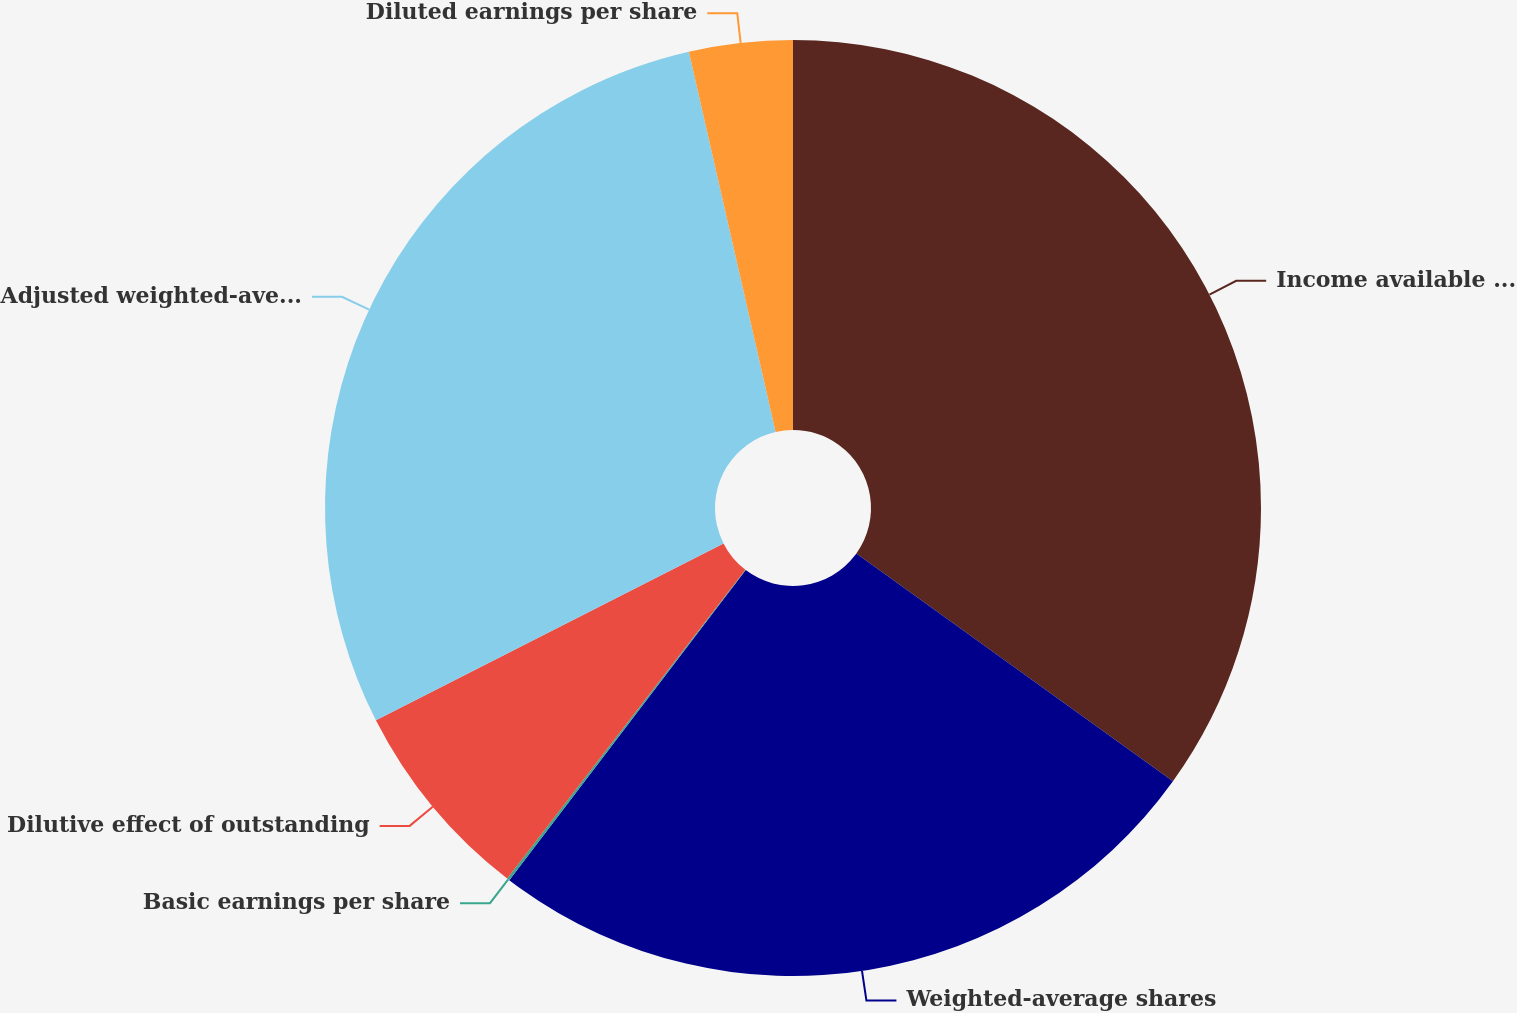Convert chart to OTSL. <chart><loc_0><loc_0><loc_500><loc_500><pie_chart><fcel>Income available to common<fcel>Weighted-average shares<fcel>Basic earnings per share<fcel>Dilutive effect of outstanding<fcel>Adjusted weighted-average<fcel>Diluted earnings per share<nl><fcel>34.92%<fcel>25.44%<fcel>0.09%<fcel>7.05%<fcel>28.92%<fcel>3.57%<nl></chart> 